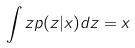<formula> <loc_0><loc_0><loc_500><loc_500>\int z p ( z | x ) d z = x</formula> 